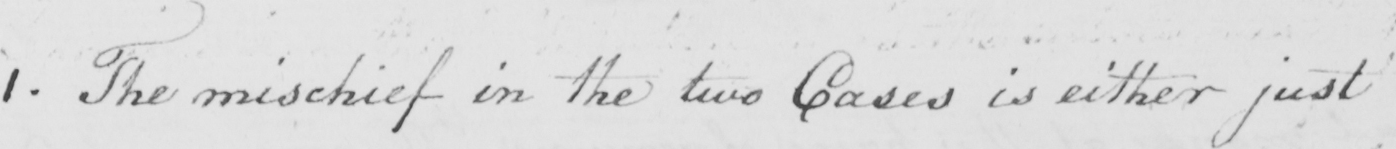What does this handwritten line say? 1 . The mischief in the two Cases is either just 